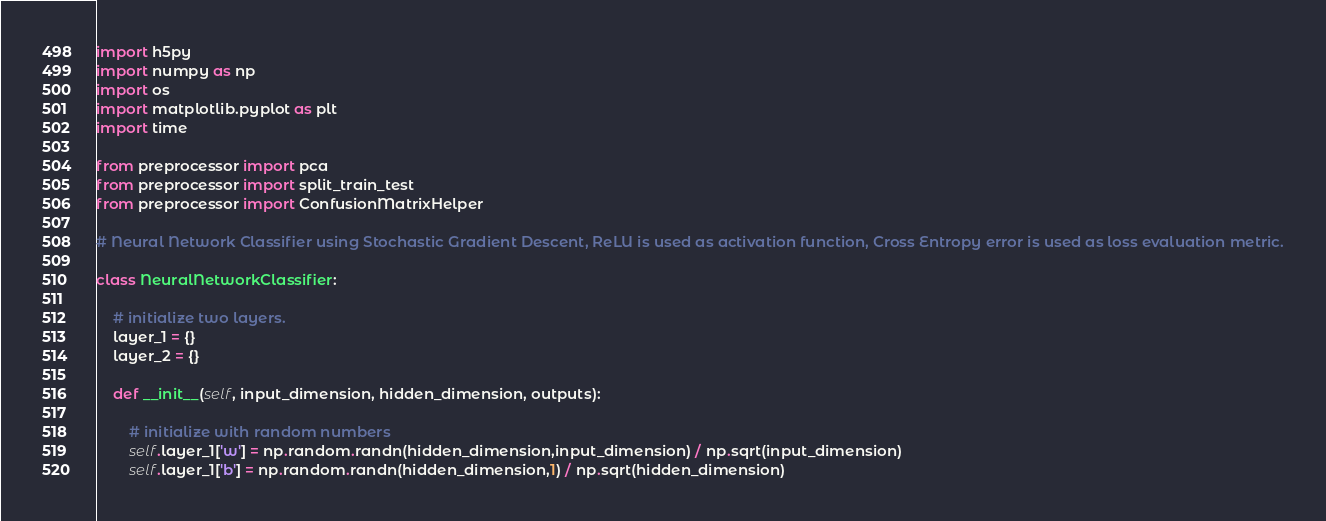<code> <loc_0><loc_0><loc_500><loc_500><_Python_>import h5py
import numpy as np
import os
import matplotlib.pyplot as plt
import time

from preprocessor import pca
from preprocessor import split_train_test
from preprocessor import ConfusionMatrixHelper

# Neural Network Classifier using Stochastic Gradient Descent, ReLU is used as activation function, Cross Entropy error is used as loss evaluation metric.

class NeuralNetworkClassifier:

    # initialize two layers.
    layer_1 = {}
    layer_2 = {}

    def __init__(self, input_dimension, hidden_dimension, outputs):

        # initialize with random numbers
        self.layer_1['w'] = np.random.randn(hidden_dimension,input_dimension) / np.sqrt(input_dimension)
        self.layer_1['b'] = np.random.randn(hidden_dimension,1) / np.sqrt(hidden_dimension)</code> 